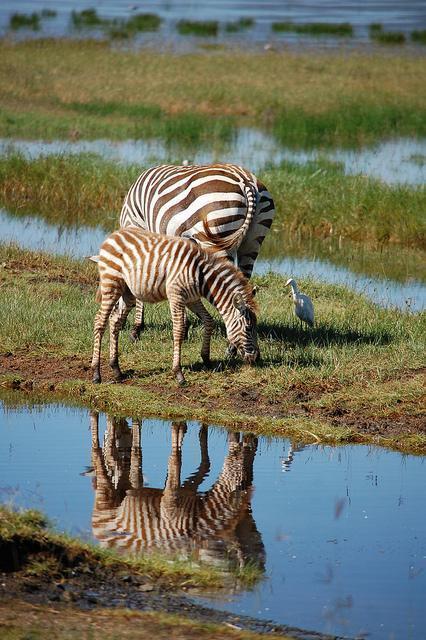Which animal is in danger from the other here?
Choose the correct response and explain in the format: 'Answer: answer
Rationale: rationale.'
Options: Bird, reflection, neither, zebra. Answer: neither.
Rationale: One is a baby and the other is probably its mother 